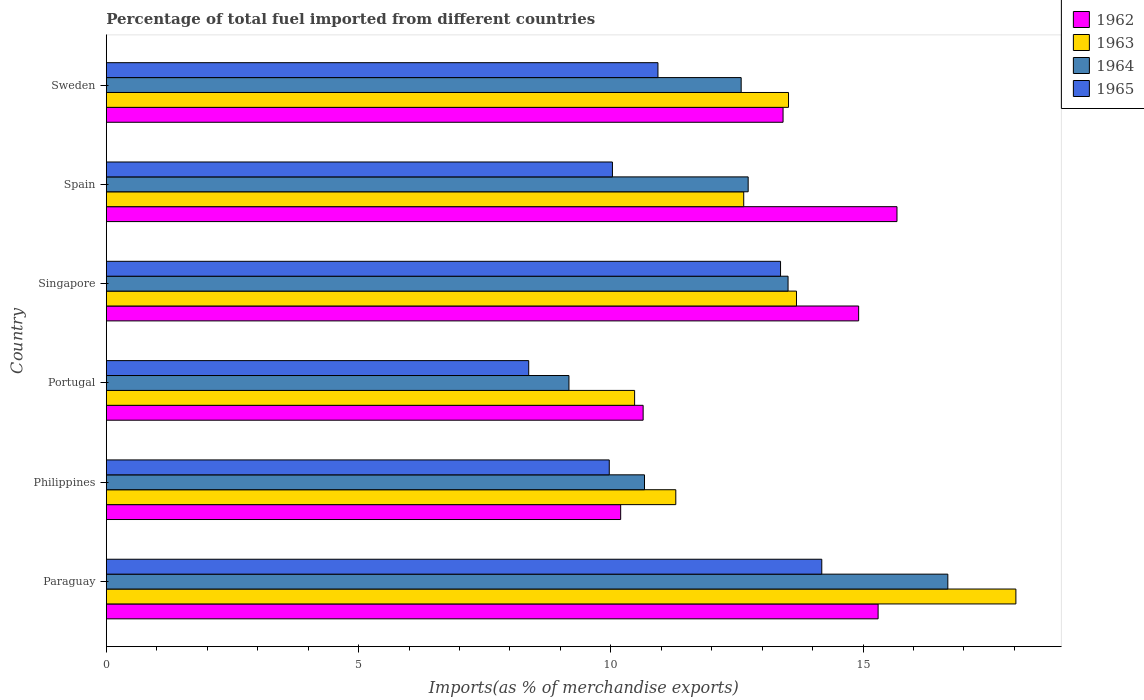How many different coloured bars are there?
Offer a terse response. 4. Are the number of bars per tick equal to the number of legend labels?
Your response must be concise. Yes. Are the number of bars on each tick of the Y-axis equal?
Provide a short and direct response. Yes. How many bars are there on the 4th tick from the bottom?
Give a very brief answer. 4. What is the label of the 4th group of bars from the top?
Your answer should be very brief. Portugal. In how many cases, is the number of bars for a given country not equal to the number of legend labels?
Ensure brevity in your answer.  0. What is the percentage of imports to different countries in 1964 in Sweden?
Provide a succinct answer. 12.58. Across all countries, what is the maximum percentage of imports to different countries in 1963?
Give a very brief answer. 18.03. Across all countries, what is the minimum percentage of imports to different countries in 1962?
Make the answer very short. 10.2. In which country was the percentage of imports to different countries in 1963 maximum?
Your answer should be compact. Paraguay. In which country was the percentage of imports to different countries in 1962 minimum?
Your response must be concise. Philippines. What is the total percentage of imports to different countries in 1965 in the graph?
Provide a short and direct response. 66.86. What is the difference between the percentage of imports to different countries in 1962 in Portugal and that in Singapore?
Offer a very short reply. -4.27. What is the difference between the percentage of imports to different countries in 1964 in Paraguay and the percentage of imports to different countries in 1965 in Spain?
Ensure brevity in your answer.  6.65. What is the average percentage of imports to different countries in 1963 per country?
Your answer should be very brief. 13.27. What is the difference between the percentage of imports to different countries in 1964 and percentage of imports to different countries in 1963 in Portugal?
Make the answer very short. -1.3. What is the ratio of the percentage of imports to different countries in 1963 in Paraguay to that in Portugal?
Keep it short and to the point. 1.72. What is the difference between the highest and the second highest percentage of imports to different countries in 1962?
Provide a short and direct response. 0.37. What is the difference between the highest and the lowest percentage of imports to different countries in 1964?
Ensure brevity in your answer.  7.51. What does the 1st bar from the top in Philippines represents?
Offer a very short reply. 1965. What does the 4th bar from the bottom in Philippines represents?
Ensure brevity in your answer.  1965. Are all the bars in the graph horizontal?
Offer a terse response. Yes. How many countries are there in the graph?
Provide a short and direct response. 6. What is the difference between two consecutive major ticks on the X-axis?
Provide a short and direct response. 5. Are the values on the major ticks of X-axis written in scientific E-notation?
Your response must be concise. No. Where does the legend appear in the graph?
Ensure brevity in your answer.  Top right. What is the title of the graph?
Offer a terse response. Percentage of total fuel imported from different countries. What is the label or title of the X-axis?
Provide a succinct answer. Imports(as % of merchandise exports). What is the Imports(as % of merchandise exports) in 1962 in Paraguay?
Ensure brevity in your answer.  15.3. What is the Imports(as % of merchandise exports) in 1963 in Paraguay?
Offer a very short reply. 18.03. What is the Imports(as % of merchandise exports) of 1964 in Paraguay?
Your response must be concise. 16.68. What is the Imports(as % of merchandise exports) in 1965 in Paraguay?
Give a very brief answer. 14.18. What is the Imports(as % of merchandise exports) in 1962 in Philippines?
Offer a very short reply. 10.2. What is the Imports(as % of merchandise exports) of 1963 in Philippines?
Ensure brevity in your answer.  11.29. What is the Imports(as % of merchandise exports) of 1964 in Philippines?
Give a very brief answer. 10.67. What is the Imports(as % of merchandise exports) in 1965 in Philippines?
Give a very brief answer. 9.97. What is the Imports(as % of merchandise exports) of 1962 in Portugal?
Provide a short and direct response. 10.64. What is the Imports(as % of merchandise exports) of 1963 in Portugal?
Provide a succinct answer. 10.47. What is the Imports(as % of merchandise exports) in 1964 in Portugal?
Keep it short and to the point. 9.17. What is the Imports(as % of merchandise exports) in 1965 in Portugal?
Give a very brief answer. 8.37. What is the Imports(as % of merchandise exports) in 1962 in Singapore?
Keep it short and to the point. 14.91. What is the Imports(as % of merchandise exports) of 1963 in Singapore?
Ensure brevity in your answer.  13.68. What is the Imports(as % of merchandise exports) of 1964 in Singapore?
Offer a very short reply. 13.51. What is the Imports(as % of merchandise exports) in 1965 in Singapore?
Your answer should be compact. 13.37. What is the Imports(as % of merchandise exports) in 1962 in Spain?
Offer a terse response. 15.67. What is the Imports(as % of merchandise exports) of 1963 in Spain?
Offer a terse response. 12.64. What is the Imports(as % of merchandise exports) of 1964 in Spain?
Make the answer very short. 12.72. What is the Imports(as % of merchandise exports) of 1965 in Spain?
Offer a terse response. 10.03. What is the Imports(as % of merchandise exports) of 1962 in Sweden?
Offer a very short reply. 13.42. What is the Imports(as % of merchandise exports) in 1963 in Sweden?
Your answer should be compact. 13.52. What is the Imports(as % of merchandise exports) in 1964 in Sweden?
Offer a terse response. 12.58. What is the Imports(as % of merchandise exports) of 1965 in Sweden?
Make the answer very short. 10.93. Across all countries, what is the maximum Imports(as % of merchandise exports) in 1962?
Keep it short and to the point. 15.67. Across all countries, what is the maximum Imports(as % of merchandise exports) in 1963?
Your answer should be compact. 18.03. Across all countries, what is the maximum Imports(as % of merchandise exports) of 1964?
Ensure brevity in your answer.  16.68. Across all countries, what is the maximum Imports(as % of merchandise exports) in 1965?
Make the answer very short. 14.18. Across all countries, what is the minimum Imports(as % of merchandise exports) of 1962?
Offer a very short reply. 10.2. Across all countries, what is the minimum Imports(as % of merchandise exports) of 1963?
Make the answer very short. 10.47. Across all countries, what is the minimum Imports(as % of merchandise exports) in 1964?
Your response must be concise. 9.17. Across all countries, what is the minimum Imports(as % of merchandise exports) in 1965?
Your answer should be very brief. 8.37. What is the total Imports(as % of merchandise exports) of 1962 in the graph?
Give a very brief answer. 80.14. What is the total Imports(as % of merchandise exports) in 1963 in the graph?
Your answer should be compact. 79.63. What is the total Imports(as % of merchandise exports) of 1964 in the graph?
Your response must be concise. 75.34. What is the total Imports(as % of merchandise exports) in 1965 in the graph?
Provide a short and direct response. 66.86. What is the difference between the Imports(as % of merchandise exports) of 1962 in Paraguay and that in Philippines?
Keep it short and to the point. 5.1. What is the difference between the Imports(as % of merchandise exports) in 1963 in Paraguay and that in Philippines?
Your answer should be compact. 6.74. What is the difference between the Imports(as % of merchandise exports) of 1964 in Paraguay and that in Philippines?
Offer a terse response. 6.01. What is the difference between the Imports(as % of merchandise exports) of 1965 in Paraguay and that in Philippines?
Offer a terse response. 4.21. What is the difference between the Imports(as % of merchandise exports) in 1962 in Paraguay and that in Portugal?
Ensure brevity in your answer.  4.66. What is the difference between the Imports(as % of merchandise exports) of 1963 in Paraguay and that in Portugal?
Make the answer very short. 7.56. What is the difference between the Imports(as % of merchandise exports) in 1964 in Paraguay and that in Portugal?
Provide a succinct answer. 7.51. What is the difference between the Imports(as % of merchandise exports) of 1965 in Paraguay and that in Portugal?
Provide a short and direct response. 5.81. What is the difference between the Imports(as % of merchandise exports) of 1962 in Paraguay and that in Singapore?
Ensure brevity in your answer.  0.39. What is the difference between the Imports(as % of merchandise exports) in 1963 in Paraguay and that in Singapore?
Offer a terse response. 4.35. What is the difference between the Imports(as % of merchandise exports) of 1964 in Paraguay and that in Singapore?
Provide a short and direct response. 3.17. What is the difference between the Imports(as % of merchandise exports) in 1965 in Paraguay and that in Singapore?
Offer a terse response. 0.82. What is the difference between the Imports(as % of merchandise exports) in 1962 in Paraguay and that in Spain?
Keep it short and to the point. -0.37. What is the difference between the Imports(as % of merchandise exports) in 1963 in Paraguay and that in Spain?
Ensure brevity in your answer.  5.4. What is the difference between the Imports(as % of merchandise exports) in 1964 in Paraguay and that in Spain?
Keep it short and to the point. 3.96. What is the difference between the Imports(as % of merchandise exports) in 1965 in Paraguay and that in Spain?
Make the answer very short. 4.15. What is the difference between the Imports(as % of merchandise exports) in 1962 in Paraguay and that in Sweden?
Ensure brevity in your answer.  1.88. What is the difference between the Imports(as % of merchandise exports) of 1963 in Paraguay and that in Sweden?
Offer a very short reply. 4.51. What is the difference between the Imports(as % of merchandise exports) of 1964 in Paraguay and that in Sweden?
Offer a very short reply. 4.1. What is the difference between the Imports(as % of merchandise exports) of 1965 in Paraguay and that in Sweden?
Provide a short and direct response. 3.25. What is the difference between the Imports(as % of merchandise exports) of 1962 in Philippines and that in Portugal?
Offer a very short reply. -0.45. What is the difference between the Imports(as % of merchandise exports) of 1963 in Philippines and that in Portugal?
Your response must be concise. 0.82. What is the difference between the Imports(as % of merchandise exports) in 1964 in Philippines and that in Portugal?
Offer a terse response. 1.5. What is the difference between the Imports(as % of merchandise exports) in 1965 in Philippines and that in Portugal?
Offer a very short reply. 1.6. What is the difference between the Imports(as % of merchandise exports) of 1962 in Philippines and that in Singapore?
Your response must be concise. -4.72. What is the difference between the Imports(as % of merchandise exports) of 1963 in Philippines and that in Singapore?
Make the answer very short. -2.39. What is the difference between the Imports(as % of merchandise exports) in 1964 in Philippines and that in Singapore?
Provide a short and direct response. -2.85. What is the difference between the Imports(as % of merchandise exports) in 1965 in Philippines and that in Singapore?
Your answer should be compact. -3.4. What is the difference between the Imports(as % of merchandise exports) of 1962 in Philippines and that in Spain?
Your answer should be very brief. -5.48. What is the difference between the Imports(as % of merchandise exports) in 1963 in Philippines and that in Spain?
Give a very brief answer. -1.35. What is the difference between the Imports(as % of merchandise exports) in 1964 in Philippines and that in Spain?
Offer a very short reply. -2.05. What is the difference between the Imports(as % of merchandise exports) in 1965 in Philippines and that in Spain?
Keep it short and to the point. -0.06. What is the difference between the Imports(as % of merchandise exports) in 1962 in Philippines and that in Sweden?
Offer a terse response. -3.22. What is the difference between the Imports(as % of merchandise exports) of 1963 in Philippines and that in Sweden?
Keep it short and to the point. -2.23. What is the difference between the Imports(as % of merchandise exports) of 1964 in Philippines and that in Sweden?
Offer a terse response. -1.92. What is the difference between the Imports(as % of merchandise exports) of 1965 in Philippines and that in Sweden?
Provide a succinct answer. -0.96. What is the difference between the Imports(as % of merchandise exports) in 1962 in Portugal and that in Singapore?
Offer a very short reply. -4.27. What is the difference between the Imports(as % of merchandise exports) in 1963 in Portugal and that in Singapore?
Ensure brevity in your answer.  -3.21. What is the difference between the Imports(as % of merchandise exports) of 1964 in Portugal and that in Singapore?
Your answer should be compact. -4.34. What is the difference between the Imports(as % of merchandise exports) in 1965 in Portugal and that in Singapore?
Your response must be concise. -4.99. What is the difference between the Imports(as % of merchandise exports) of 1962 in Portugal and that in Spain?
Make the answer very short. -5.03. What is the difference between the Imports(as % of merchandise exports) of 1963 in Portugal and that in Spain?
Ensure brevity in your answer.  -2.16. What is the difference between the Imports(as % of merchandise exports) of 1964 in Portugal and that in Spain?
Your answer should be compact. -3.55. What is the difference between the Imports(as % of merchandise exports) of 1965 in Portugal and that in Spain?
Offer a terse response. -1.66. What is the difference between the Imports(as % of merchandise exports) of 1962 in Portugal and that in Sweden?
Your answer should be very brief. -2.77. What is the difference between the Imports(as % of merchandise exports) of 1963 in Portugal and that in Sweden?
Your response must be concise. -3.05. What is the difference between the Imports(as % of merchandise exports) of 1964 in Portugal and that in Sweden?
Your response must be concise. -3.41. What is the difference between the Imports(as % of merchandise exports) in 1965 in Portugal and that in Sweden?
Make the answer very short. -2.56. What is the difference between the Imports(as % of merchandise exports) of 1962 in Singapore and that in Spain?
Offer a terse response. -0.76. What is the difference between the Imports(as % of merchandise exports) in 1963 in Singapore and that in Spain?
Offer a terse response. 1.05. What is the difference between the Imports(as % of merchandise exports) of 1964 in Singapore and that in Spain?
Make the answer very short. 0.79. What is the difference between the Imports(as % of merchandise exports) in 1965 in Singapore and that in Spain?
Your response must be concise. 3.33. What is the difference between the Imports(as % of merchandise exports) of 1962 in Singapore and that in Sweden?
Provide a short and direct response. 1.5. What is the difference between the Imports(as % of merchandise exports) of 1963 in Singapore and that in Sweden?
Your response must be concise. 0.16. What is the difference between the Imports(as % of merchandise exports) of 1964 in Singapore and that in Sweden?
Make the answer very short. 0.93. What is the difference between the Imports(as % of merchandise exports) of 1965 in Singapore and that in Sweden?
Keep it short and to the point. 2.43. What is the difference between the Imports(as % of merchandise exports) of 1962 in Spain and that in Sweden?
Offer a terse response. 2.26. What is the difference between the Imports(as % of merchandise exports) of 1963 in Spain and that in Sweden?
Give a very brief answer. -0.89. What is the difference between the Imports(as % of merchandise exports) of 1964 in Spain and that in Sweden?
Keep it short and to the point. 0.14. What is the difference between the Imports(as % of merchandise exports) in 1965 in Spain and that in Sweden?
Keep it short and to the point. -0.9. What is the difference between the Imports(as % of merchandise exports) of 1962 in Paraguay and the Imports(as % of merchandise exports) of 1963 in Philippines?
Your answer should be compact. 4.01. What is the difference between the Imports(as % of merchandise exports) of 1962 in Paraguay and the Imports(as % of merchandise exports) of 1964 in Philippines?
Ensure brevity in your answer.  4.63. What is the difference between the Imports(as % of merchandise exports) of 1962 in Paraguay and the Imports(as % of merchandise exports) of 1965 in Philippines?
Give a very brief answer. 5.33. What is the difference between the Imports(as % of merchandise exports) of 1963 in Paraguay and the Imports(as % of merchandise exports) of 1964 in Philippines?
Provide a short and direct response. 7.36. What is the difference between the Imports(as % of merchandise exports) in 1963 in Paraguay and the Imports(as % of merchandise exports) in 1965 in Philippines?
Provide a succinct answer. 8.06. What is the difference between the Imports(as % of merchandise exports) in 1964 in Paraguay and the Imports(as % of merchandise exports) in 1965 in Philippines?
Ensure brevity in your answer.  6.71. What is the difference between the Imports(as % of merchandise exports) in 1962 in Paraguay and the Imports(as % of merchandise exports) in 1963 in Portugal?
Ensure brevity in your answer.  4.83. What is the difference between the Imports(as % of merchandise exports) in 1962 in Paraguay and the Imports(as % of merchandise exports) in 1964 in Portugal?
Give a very brief answer. 6.13. What is the difference between the Imports(as % of merchandise exports) of 1962 in Paraguay and the Imports(as % of merchandise exports) of 1965 in Portugal?
Offer a very short reply. 6.93. What is the difference between the Imports(as % of merchandise exports) of 1963 in Paraguay and the Imports(as % of merchandise exports) of 1964 in Portugal?
Offer a terse response. 8.86. What is the difference between the Imports(as % of merchandise exports) in 1963 in Paraguay and the Imports(as % of merchandise exports) in 1965 in Portugal?
Keep it short and to the point. 9.66. What is the difference between the Imports(as % of merchandise exports) in 1964 in Paraguay and the Imports(as % of merchandise exports) in 1965 in Portugal?
Provide a succinct answer. 8.31. What is the difference between the Imports(as % of merchandise exports) in 1962 in Paraguay and the Imports(as % of merchandise exports) in 1963 in Singapore?
Ensure brevity in your answer.  1.62. What is the difference between the Imports(as % of merchandise exports) in 1962 in Paraguay and the Imports(as % of merchandise exports) in 1964 in Singapore?
Provide a succinct answer. 1.79. What is the difference between the Imports(as % of merchandise exports) of 1962 in Paraguay and the Imports(as % of merchandise exports) of 1965 in Singapore?
Offer a very short reply. 1.93. What is the difference between the Imports(as % of merchandise exports) of 1963 in Paraguay and the Imports(as % of merchandise exports) of 1964 in Singapore?
Ensure brevity in your answer.  4.52. What is the difference between the Imports(as % of merchandise exports) in 1963 in Paraguay and the Imports(as % of merchandise exports) in 1965 in Singapore?
Keep it short and to the point. 4.67. What is the difference between the Imports(as % of merchandise exports) in 1964 in Paraguay and the Imports(as % of merchandise exports) in 1965 in Singapore?
Make the answer very short. 3.32. What is the difference between the Imports(as % of merchandise exports) of 1962 in Paraguay and the Imports(as % of merchandise exports) of 1963 in Spain?
Ensure brevity in your answer.  2.66. What is the difference between the Imports(as % of merchandise exports) of 1962 in Paraguay and the Imports(as % of merchandise exports) of 1964 in Spain?
Keep it short and to the point. 2.58. What is the difference between the Imports(as % of merchandise exports) in 1962 in Paraguay and the Imports(as % of merchandise exports) in 1965 in Spain?
Provide a succinct answer. 5.27. What is the difference between the Imports(as % of merchandise exports) in 1963 in Paraguay and the Imports(as % of merchandise exports) in 1964 in Spain?
Give a very brief answer. 5.31. What is the difference between the Imports(as % of merchandise exports) of 1963 in Paraguay and the Imports(as % of merchandise exports) of 1965 in Spain?
Your answer should be very brief. 8. What is the difference between the Imports(as % of merchandise exports) of 1964 in Paraguay and the Imports(as % of merchandise exports) of 1965 in Spain?
Provide a short and direct response. 6.65. What is the difference between the Imports(as % of merchandise exports) of 1962 in Paraguay and the Imports(as % of merchandise exports) of 1963 in Sweden?
Give a very brief answer. 1.78. What is the difference between the Imports(as % of merchandise exports) of 1962 in Paraguay and the Imports(as % of merchandise exports) of 1964 in Sweden?
Ensure brevity in your answer.  2.71. What is the difference between the Imports(as % of merchandise exports) in 1962 in Paraguay and the Imports(as % of merchandise exports) in 1965 in Sweden?
Provide a short and direct response. 4.36. What is the difference between the Imports(as % of merchandise exports) of 1963 in Paraguay and the Imports(as % of merchandise exports) of 1964 in Sweden?
Your answer should be compact. 5.45. What is the difference between the Imports(as % of merchandise exports) of 1963 in Paraguay and the Imports(as % of merchandise exports) of 1965 in Sweden?
Keep it short and to the point. 7.1. What is the difference between the Imports(as % of merchandise exports) of 1964 in Paraguay and the Imports(as % of merchandise exports) of 1965 in Sweden?
Your answer should be compact. 5.75. What is the difference between the Imports(as % of merchandise exports) of 1962 in Philippines and the Imports(as % of merchandise exports) of 1963 in Portugal?
Give a very brief answer. -0.28. What is the difference between the Imports(as % of merchandise exports) of 1962 in Philippines and the Imports(as % of merchandise exports) of 1964 in Portugal?
Your response must be concise. 1.03. What is the difference between the Imports(as % of merchandise exports) in 1962 in Philippines and the Imports(as % of merchandise exports) in 1965 in Portugal?
Your answer should be very brief. 1.82. What is the difference between the Imports(as % of merchandise exports) in 1963 in Philippines and the Imports(as % of merchandise exports) in 1964 in Portugal?
Your answer should be compact. 2.12. What is the difference between the Imports(as % of merchandise exports) in 1963 in Philippines and the Imports(as % of merchandise exports) in 1965 in Portugal?
Provide a short and direct response. 2.92. What is the difference between the Imports(as % of merchandise exports) of 1964 in Philippines and the Imports(as % of merchandise exports) of 1965 in Portugal?
Make the answer very short. 2.3. What is the difference between the Imports(as % of merchandise exports) of 1962 in Philippines and the Imports(as % of merchandise exports) of 1963 in Singapore?
Offer a very short reply. -3.49. What is the difference between the Imports(as % of merchandise exports) of 1962 in Philippines and the Imports(as % of merchandise exports) of 1964 in Singapore?
Make the answer very short. -3.32. What is the difference between the Imports(as % of merchandise exports) of 1962 in Philippines and the Imports(as % of merchandise exports) of 1965 in Singapore?
Ensure brevity in your answer.  -3.17. What is the difference between the Imports(as % of merchandise exports) of 1963 in Philippines and the Imports(as % of merchandise exports) of 1964 in Singapore?
Ensure brevity in your answer.  -2.23. What is the difference between the Imports(as % of merchandise exports) in 1963 in Philippines and the Imports(as % of merchandise exports) in 1965 in Singapore?
Provide a short and direct response. -2.08. What is the difference between the Imports(as % of merchandise exports) in 1964 in Philippines and the Imports(as % of merchandise exports) in 1965 in Singapore?
Give a very brief answer. -2.7. What is the difference between the Imports(as % of merchandise exports) of 1962 in Philippines and the Imports(as % of merchandise exports) of 1963 in Spain?
Your answer should be compact. -2.44. What is the difference between the Imports(as % of merchandise exports) in 1962 in Philippines and the Imports(as % of merchandise exports) in 1964 in Spain?
Offer a terse response. -2.53. What is the difference between the Imports(as % of merchandise exports) in 1962 in Philippines and the Imports(as % of merchandise exports) in 1965 in Spain?
Offer a terse response. 0.16. What is the difference between the Imports(as % of merchandise exports) in 1963 in Philippines and the Imports(as % of merchandise exports) in 1964 in Spain?
Keep it short and to the point. -1.43. What is the difference between the Imports(as % of merchandise exports) of 1963 in Philippines and the Imports(as % of merchandise exports) of 1965 in Spain?
Offer a terse response. 1.26. What is the difference between the Imports(as % of merchandise exports) of 1964 in Philippines and the Imports(as % of merchandise exports) of 1965 in Spain?
Give a very brief answer. 0.64. What is the difference between the Imports(as % of merchandise exports) in 1962 in Philippines and the Imports(as % of merchandise exports) in 1963 in Sweden?
Ensure brevity in your answer.  -3.33. What is the difference between the Imports(as % of merchandise exports) of 1962 in Philippines and the Imports(as % of merchandise exports) of 1964 in Sweden?
Your answer should be very brief. -2.39. What is the difference between the Imports(as % of merchandise exports) of 1962 in Philippines and the Imports(as % of merchandise exports) of 1965 in Sweden?
Make the answer very short. -0.74. What is the difference between the Imports(as % of merchandise exports) of 1963 in Philippines and the Imports(as % of merchandise exports) of 1964 in Sweden?
Offer a very short reply. -1.3. What is the difference between the Imports(as % of merchandise exports) in 1963 in Philippines and the Imports(as % of merchandise exports) in 1965 in Sweden?
Ensure brevity in your answer.  0.35. What is the difference between the Imports(as % of merchandise exports) of 1964 in Philippines and the Imports(as % of merchandise exports) of 1965 in Sweden?
Provide a succinct answer. -0.27. What is the difference between the Imports(as % of merchandise exports) of 1962 in Portugal and the Imports(as % of merchandise exports) of 1963 in Singapore?
Your answer should be very brief. -3.04. What is the difference between the Imports(as % of merchandise exports) in 1962 in Portugal and the Imports(as % of merchandise exports) in 1964 in Singapore?
Your answer should be compact. -2.87. What is the difference between the Imports(as % of merchandise exports) of 1962 in Portugal and the Imports(as % of merchandise exports) of 1965 in Singapore?
Ensure brevity in your answer.  -2.72. What is the difference between the Imports(as % of merchandise exports) in 1963 in Portugal and the Imports(as % of merchandise exports) in 1964 in Singapore?
Keep it short and to the point. -3.04. What is the difference between the Imports(as % of merchandise exports) in 1963 in Portugal and the Imports(as % of merchandise exports) in 1965 in Singapore?
Ensure brevity in your answer.  -2.89. What is the difference between the Imports(as % of merchandise exports) in 1964 in Portugal and the Imports(as % of merchandise exports) in 1965 in Singapore?
Offer a terse response. -4.19. What is the difference between the Imports(as % of merchandise exports) of 1962 in Portugal and the Imports(as % of merchandise exports) of 1963 in Spain?
Your answer should be very brief. -1.99. What is the difference between the Imports(as % of merchandise exports) in 1962 in Portugal and the Imports(as % of merchandise exports) in 1964 in Spain?
Make the answer very short. -2.08. What is the difference between the Imports(as % of merchandise exports) of 1962 in Portugal and the Imports(as % of merchandise exports) of 1965 in Spain?
Provide a succinct answer. 0.61. What is the difference between the Imports(as % of merchandise exports) in 1963 in Portugal and the Imports(as % of merchandise exports) in 1964 in Spain?
Give a very brief answer. -2.25. What is the difference between the Imports(as % of merchandise exports) of 1963 in Portugal and the Imports(as % of merchandise exports) of 1965 in Spain?
Offer a terse response. 0.44. What is the difference between the Imports(as % of merchandise exports) of 1964 in Portugal and the Imports(as % of merchandise exports) of 1965 in Spain?
Your response must be concise. -0.86. What is the difference between the Imports(as % of merchandise exports) in 1962 in Portugal and the Imports(as % of merchandise exports) in 1963 in Sweden?
Your answer should be very brief. -2.88. What is the difference between the Imports(as % of merchandise exports) in 1962 in Portugal and the Imports(as % of merchandise exports) in 1964 in Sweden?
Make the answer very short. -1.94. What is the difference between the Imports(as % of merchandise exports) in 1962 in Portugal and the Imports(as % of merchandise exports) in 1965 in Sweden?
Your answer should be very brief. -0.29. What is the difference between the Imports(as % of merchandise exports) in 1963 in Portugal and the Imports(as % of merchandise exports) in 1964 in Sweden?
Give a very brief answer. -2.11. What is the difference between the Imports(as % of merchandise exports) in 1963 in Portugal and the Imports(as % of merchandise exports) in 1965 in Sweden?
Make the answer very short. -0.46. What is the difference between the Imports(as % of merchandise exports) of 1964 in Portugal and the Imports(as % of merchandise exports) of 1965 in Sweden?
Provide a succinct answer. -1.76. What is the difference between the Imports(as % of merchandise exports) of 1962 in Singapore and the Imports(as % of merchandise exports) of 1963 in Spain?
Offer a terse response. 2.28. What is the difference between the Imports(as % of merchandise exports) of 1962 in Singapore and the Imports(as % of merchandise exports) of 1964 in Spain?
Offer a very short reply. 2.19. What is the difference between the Imports(as % of merchandise exports) in 1962 in Singapore and the Imports(as % of merchandise exports) in 1965 in Spain?
Your answer should be compact. 4.88. What is the difference between the Imports(as % of merchandise exports) in 1963 in Singapore and the Imports(as % of merchandise exports) in 1964 in Spain?
Make the answer very short. 0.96. What is the difference between the Imports(as % of merchandise exports) in 1963 in Singapore and the Imports(as % of merchandise exports) in 1965 in Spain?
Give a very brief answer. 3.65. What is the difference between the Imports(as % of merchandise exports) in 1964 in Singapore and the Imports(as % of merchandise exports) in 1965 in Spain?
Offer a very short reply. 3.48. What is the difference between the Imports(as % of merchandise exports) of 1962 in Singapore and the Imports(as % of merchandise exports) of 1963 in Sweden?
Your answer should be compact. 1.39. What is the difference between the Imports(as % of merchandise exports) in 1962 in Singapore and the Imports(as % of merchandise exports) in 1964 in Sweden?
Provide a succinct answer. 2.33. What is the difference between the Imports(as % of merchandise exports) in 1962 in Singapore and the Imports(as % of merchandise exports) in 1965 in Sweden?
Offer a very short reply. 3.98. What is the difference between the Imports(as % of merchandise exports) of 1963 in Singapore and the Imports(as % of merchandise exports) of 1964 in Sweden?
Offer a terse response. 1.1. What is the difference between the Imports(as % of merchandise exports) in 1963 in Singapore and the Imports(as % of merchandise exports) in 1965 in Sweden?
Your answer should be compact. 2.75. What is the difference between the Imports(as % of merchandise exports) of 1964 in Singapore and the Imports(as % of merchandise exports) of 1965 in Sweden?
Your answer should be compact. 2.58. What is the difference between the Imports(as % of merchandise exports) in 1962 in Spain and the Imports(as % of merchandise exports) in 1963 in Sweden?
Keep it short and to the point. 2.15. What is the difference between the Imports(as % of merchandise exports) of 1962 in Spain and the Imports(as % of merchandise exports) of 1964 in Sweden?
Your answer should be compact. 3.09. What is the difference between the Imports(as % of merchandise exports) in 1962 in Spain and the Imports(as % of merchandise exports) in 1965 in Sweden?
Your answer should be compact. 4.74. What is the difference between the Imports(as % of merchandise exports) in 1963 in Spain and the Imports(as % of merchandise exports) in 1964 in Sweden?
Make the answer very short. 0.05. What is the difference between the Imports(as % of merchandise exports) in 1963 in Spain and the Imports(as % of merchandise exports) in 1965 in Sweden?
Keep it short and to the point. 1.7. What is the difference between the Imports(as % of merchandise exports) of 1964 in Spain and the Imports(as % of merchandise exports) of 1965 in Sweden?
Ensure brevity in your answer.  1.79. What is the average Imports(as % of merchandise exports) of 1962 per country?
Make the answer very short. 13.36. What is the average Imports(as % of merchandise exports) in 1963 per country?
Make the answer very short. 13.27. What is the average Imports(as % of merchandise exports) of 1964 per country?
Keep it short and to the point. 12.56. What is the average Imports(as % of merchandise exports) of 1965 per country?
Your response must be concise. 11.14. What is the difference between the Imports(as % of merchandise exports) of 1962 and Imports(as % of merchandise exports) of 1963 in Paraguay?
Ensure brevity in your answer.  -2.73. What is the difference between the Imports(as % of merchandise exports) of 1962 and Imports(as % of merchandise exports) of 1964 in Paraguay?
Ensure brevity in your answer.  -1.38. What is the difference between the Imports(as % of merchandise exports) in 1962 and Imports(as % of merchandise exports) in 1965 in Paraguay?
Offer a very short reply. 1.12. What is the difference between the Imports(as % of merchandise exports) in 1963 and Imports(as % of merchandise exports) in 1964 in Paraguay?
Give a very brief answer. 1.35. What is the difference between the Imports(as % of merchandise exports) in 1963 and Imports(as % of merchandise exports) in 1965 in Paraguay?
Your answer should be very brief. 3.85. What is the difference between the Imports(as % of merchandise exports) of 1964 and Imports(as % of merchandise exports) of 1965 in Paraguay?
Keep it short and to the point. 2.5. What is the difference between the Imports(as % of merchandise exports) of 1962 and Imports(as % of merchandise exports) of 1963 in Philippines?
Give a very brief answer. -1.09. What is the difference between the Imports(as % of merchandise exports) of 1962 and Imports(as % of merchandise exports) of 1964 in Philippines?
Provide a short and direct response. -0.47. What is the difference between the Imports(as % of merchandise exports) of 1962 and Imports(as % of merchandise exports) of 1965 in Philippines?
Provide a succinct answer. 0.23. What is the difference between the Imports(as % of merchandise exports) in 1963 and Imports(as % of merchandise exports) in 1964 in Philippines?
Offer a terse response. 0.62. What is the difference between the Imports(as % of merchandise exports) in 1963 and Imports(as % of merchandise exports) in 1965 in Philippines?
Provide a succinct answer. 1.32. What is the difference between the Imports(as % of merchandise exports) of 1964 and Imports(as % of merchandise exports) of 1965 in Philippines?
Provide a succinct answer. 0.7. What is the difference between the Imports(as % of merchandise exports) in 1962 and Imports(as % of merchandise exports) in 1963 in Portugal?
Provide a succinct answer. 0.17. What is the difference between the Imports(as % of merchandise exports) in 1962 and Imports(as % of merchandise exports) in 1964 in Portugal?
Keep it short and to the point. 1.47. What is the difference between the Imports(as % of merchandise exports) of 1962 and Imports(as % of merchandise exports) of 1965 in Portugal?
Provide a short and direct response. 2.27. What is the difference between the Imports(as % of merchandise exports) in 1963 and Imports(as % of merchandise exports) in 1964 in Portugal?
Make the answer very short. 1.3. What is the difference between the Imports(as % of merchandise exports) in 1963 and Imports(as % of merchandise exports) in 1965 in Portugal?
Ensure brevity in your answer.  2.1. What is the difference between the Imports(as % of merchandise exports) in 1964 and Imports(as % of merchandise exports) in 1965 in Portugal?
Ensure brevity in your answer.  0.8. What is the difference between the Imports(as % of merchandise exports) of 1962 and Imports(as % of merchandise exports) of 1963 in Singapore?
Offer a very short reply. 1.23. What is the difference between the Imports(as % of merchandise exports) of 1962 and Imports(as % of merchandise exports) of 1964 in Singapore?
Ensure brevity in your answer.  1.4. What is the difference between the Imports(as % of merchandise exports) of 1962 and Imports(as % of merchandise exports) of 1965 in Singapore?
Your response must be concise. 1.55. What is the difference between the Imports(as % of merchandise exports) of 1963 and Imports(as % of merchandise exports) of 1964 in Singapore?
Give a very brief answer. 0.17. What is the difference between the Imports(as % of merchandise exports) of 1963 and Imports(as % of merchandise exports) of 1965 in Singapore?
Give a very brief answer. 0.32. What is the difference between the Imports(as % of merchandise exports) in 1964 and Imports(as % of merchandise exports) in 1965 in Singapore?
Offer a terse response. 0.15. What is the difference between the Imports(as % of merchandise exports) of 1962 and Imports(as % of merchandise exports) of 1963 in Spain?
Keep it short and to the point. 3.04. What is the difference between the Imports(as % of merchandise exports) in 1962 and Imports(as % of merchandise exports) in 1964 in Spain?
Provide a succinct answer. 2.95. What is the difference between the Imports(as % of merchandise exports) in 1962 and Imports(as % of merchandise exports) in 1965 in Spain?
Your answer should be compact. 5.64. What is the difference between the Imports(as % of merchandise exports) of 1963 and Imports(as % of merchandise exports) of 1964 in Spain?
Give a very brief answer. -0.09. What is the difference between the Imports(as % of merchandise exports) in 1963 and Imports(as % of merchandise exports) in 1965 in Spain?
Your answer should be very brief. 2.6. What is the difference between the Imports(as % of merchandise exports) of 1964 and Imports(as % of merchandise exports) of 1965 in Spain?
Your answer should be compact. 2.69. What is the difference between the Imports(as % of merchandise exports) of 1962 and Imports(as % of merchandise exports) of 1963 in Sweden?
Offer a very short reply. -0.11. What is the difference between the Imports(as % of merchandise exports) in 1962 and Imports(as % of merchandise exports) in 1964 in Sweden?
Keep it short and to the point. 0.83. What is the difference between the Imports(as % of merchandise exports) in 1962 and Imports(as % of merchandise exports) in 1965 in Sweden?
Provide a short and direct response. 2.48. What is the difference between the Imports(as % of merchandise exports) of 1963 and Imports(as % of merchandise exports) of 1964 in Sweden?
Your answer should be compact. 0.94. What is the difference between the Imports(as % of merchandise exports) in 1963 and Imports(as % of merchandise exports) in 1965 in Sweden?
Provide a succinct answer. 2.59. What is the difference between the Imports(as % of merchandise exports) in 1964 and Imports(as % of merchandise exports) in 1965 in Sweden?
Offer a terse response. 1.65. What is the ratio of the Imports(as % of merchandise exports) of 1962 in Paraguay to that in Philippines?
Give a very brief answer. 1.5. What is the ratio of the Imports(as % of merchandise exports) of 1963 in Paraguay to that in Philippines?
Give a very brief answer. 1.6. What is the ratio of the Imports(as % of merchandise exports) of 1964 in Paraguay to that in Philippines?
Ensure brevity in your answer.  1.56. What is the ratio of the Imports(as % of merchandise exports) in 1965 in Paraguay to that in Philippines?
Offer a very short reply. 1.42. What is the ratio of the Imports(as % of merchandise exports) in 1962 in Paraguay to that in Portugal?
Give a very brief answer. 1.44. What is the ratio of the Imports(as % of merchandise exports) in 1963 in Paraguay to that in Portugal?
Ensure brevity in your answer.  1.72. What is the ratio of the Imports(as % of merchandise exports) of 1964 in Paraguay to that in Portugal?
Provide a short and direct response. 1.82. What is the ratio of the Imports(as % of merchandise exports) of 1965 in Paraguay to that in Portugal?
Your answer should be compact. 1.69. What is the ratio of the Imports(as % of merchandise exports) of 1962 in Paraguay to that in Singapore?
Give a very brief answer. 1.03. What is the ratio of the Imports(as % of merchandise exports) in 1963 in Paraguay to that in Singapore?
Your answer should be very brief. 1.32. What is the ratio of the Imports(as % of merchandise exports) in 1964 in Paraguay to that in Singapore?
Offer a terse response. 1.23. What is the ratio of the Imports(as % of merchandise exports) in 1965 in Paraguay to that in Singapore?
Ensure brevity in your answer.  1.06. What is the ratio of the Imports(as % of merchandise exports) in 1962 in Paraguay to that in Spain?
Offer a very short reply. 0.98. What is the ratio of the Imports(as % of merchandise exports) in 1963 in Paraguay to that in Spain?
Offer a terse response. 1.43. What is the ratio of the Imports(as % of merchandise exports) of 1964 in Paraguay to that in Spain?
Your response must be concise. 1.31. What is the ratio of the Imports(as % of merchandise exports) in 1965 in Paraguay to that in Spain?
Offer a very short reply. 1.41. What is the ratio of the Imports(as % of merchandise exports) in 1962 in Paraguay to that in Sweden?
Your answer should be very brief. 1.14. What is the ratio of the Imports(as % of merchandise exports) of 1963 in Paraguay to that in Sweden?
Provide a short and direct response. 1.33. What is the ratio of the Imports(as % of merchandise exports) in 1964 in Paraguay to that in Sweden?
Ensure brevity in your answer.  1.33. What is the ratio of the Imports(as % of merchandise exports) in 1965 in Paraguay to that in Sweden?
Offer a terse response. 1.3. What is the ratio of the Imports(as % of merchandise exports) of 1962 in Philippines to that in Portugal?
Your answer should be compact. 0.96. What is the ratio of the Imports(as % of merchandise exports) in 1963 in Philippines to that in Portugal?
Your response must be concise. 1.08. What is the ratio of the Imports(as % of merchandise exports) in 1964 in Philippines to that in Portugal?
Your answer should be compact. 1.16. What is the ratio of the Imports(as % of merchandise exports) in 1965 in Philippines to that in Portugal?
Your response must be concise. 1.19. What is the ratio of the Imports(as % of merchandise exports) in 1962 in Philippines to that in Singapore?
Offer a terse response. 0.68. What is the ratio of the Imports(as % of merchandise exports) in 1963 in Philippines to that in Singapore?
Ensure brevity in your answer.  0.83. What is the ratio of the Imports(as % of merchandise exports) in 1964 in Philippines to that in Singapore?
Your answer should be compact. 0.79. What is the ratio of the Imports(as % of merchandise exports) in 1965 in Philippines to that in Singapore?
Ensure brevity in your answer.  0.75. What is the ratio of the Imports(as % of merchandise exports) of 1962 in Philippines to that in Spain?
Your answer should be very brief. 0.65. What is the ratio of the Imports(as % of merchandise exports) of 1963 in Philippines to that in Spain?
Ensure brevity in your answer.  0.89. What is the ratio of the Imports(as % of merchandise exports) of 1964 in Philippines to that in Spain?
Provide a succinct answer. 0.84. What is the ratio of the Imports(as % of merchandise exports) of 1965 in Philippines to that in Spain?
Give a very brief answer. 0.99. What is the ratio of the Imports(as % of merchandise exports) of 1962 in Philippines to that in Sweden?
Give a very brief answer. 0.76. What is the ratio of the Imports(as % of merchandise exports) in 1963 in Philippines to that in Sweden?
Give a very brief answer. 0.83. What is the ratio of the Imports(as % of merchandise exports) in 1964 in Philippines to that in Sweden?
Offer a terse response. 0.85. What is the ratio of the Imports(as % of merchandise exports) in 1965 in Philippines to that in Sweden?
Offer a very short reply. 0.91. What is the ratio of the Imports(as % of merchandise exports) in 1962 in Portugal to that in Singapore?
Your answer should be very brief. 0.71. What is the ratio of the Imports(as % of merchandise exports) of 1963 in Portugal to that in Singapore?
Your answer should be very brief. 0.77. What is the ratio of the Imports(as % of merchandise exports) of 1964 in Portugal to that in Singapore?
Give a very brief answer. 0.68. What is the ratio of the Imports(as % of merchandise exports) in 1965 in Portugal to that in Singapore?
Keep it short and to the point. 0.63. What is the ratio of the Imports(as % of merchandise exports) of 1962 in Portugal to that in Spain?
Offer a very short reply. 0.68. What is the ratio of the Imports(as % of merchandise exports) of 1963 in Portugal to that in Spain?
Offer a terse response. 0.83. What is the ratio of the Imports(as % of merchandise exports) in 1964 in Portugal to that in Spain?
Your answer should be very brief. 0.72. What is the ratio of the Imports(as % of merchandise exports) in 1965 in Portugal to that in Spain?
Offer a very short reply. 0.83. What is the ratio of the Imports(as % of merchandise exports) in 1962 in Portugal to that in Sweden?
Offer a terse response. 0.79. What is the ratio of the Imports(as % of merchandise exports) of 1963 in Portugal to that in Sweden?
Your response must be concise. 0.77. What is the ratio of the Imports(as % of merchandise exports) of 1964 in Portugal to that in Sweden?
Your response must be concise. 0.73. What is the ratio of the Imports(as % of merchandise exports) of 1965 in Portugal to that in Sweden?
Ensure brevity in your answer.  0.77. What is the ratio of the Imports(as % of merchandise exports) in 1962 in Singapore to that in Spain?
Offer a very short reply. 0.95. What is the ratio of the Imports(as % of merchandise exports) in 1963 in Singapore to that in Spain?
Provide a short and direct response. 1.08. What is the ratio of the Imports(as % of merchandise exports) in 1964 in Singapore to that in Spain?
Make the answer very short. 1.06. What is the ratio of the Imports(as % of merchandise exports) of 1965 in Singapore to that in Spain?
Provide a short and direct response. 1.33. What is the ratio of the Imports(as % of merchandise exports) of 1962 in Singapore to that in Sweden?
Make the answer very short. 1.11. What is the ratio of the Imports(as % of merchandise exports) of 1963 in Singapore to that in Sweden?
Ensure brevity in your answer.  1.01. What is the ratio of the Imports(as % of merchandise exports) in 1964 in Singapore to that in Sweden?
Offer a terse response. 1.07. What is the ratio of the Imports(as % of merchandise exports) of 1965 in Singapore to that in Sweden?
Your answer should be very brief. 1.22. What is the ratio of the Imports(as % of merchandise exports) in 1962 in Spain to that in Sweden?
Offer a very short reply. 1.17. What is the ratio of the Imports(as % of merchandise exports) of 1963 in Spain to that in Sweden?
Keep it short and to the point. 0.93. What is the ratio of the Imports(as % of merchandise exports) of 1965 in Spain to that in Sweden?
Ensure brevity in your answer.  0.92. What is the difference between the highest and the second highest Imports(as % of merchandise exports) of 1962?
Your answer should be compact. 0.37. What is the difference between the highest and the second highest Imports(as % of merchandise exports) in 1963?
Make the answer very short. 4.35. What is the difference between the highest and the second highest Imports(as % of merchandise exports) in 1964?
Ensure brevity in your answer.  3.17. What is the difference between the highest and the second highest Imports(as % of merchandise exports) in 1965?
Give a very brief answer. 0.82. What is the difference between the highest and the lowest Imports(as % of merchandise exports) in 1962?
Your answer should be very brief. 5.48. What is the difference between the highest and the lowest Imports(as % of merchandise exports) in 1963?
Your response must be concise. 7.56. What is the difference between the highest and the lowest Imports(as % of merchandise exports) in 1964?
Provide a succinct answer. 7.51. What is the difference between the highest and the lowest Imports(as % of merchandise exports) of 1965?
Your answer should be very brief. 5.81. 